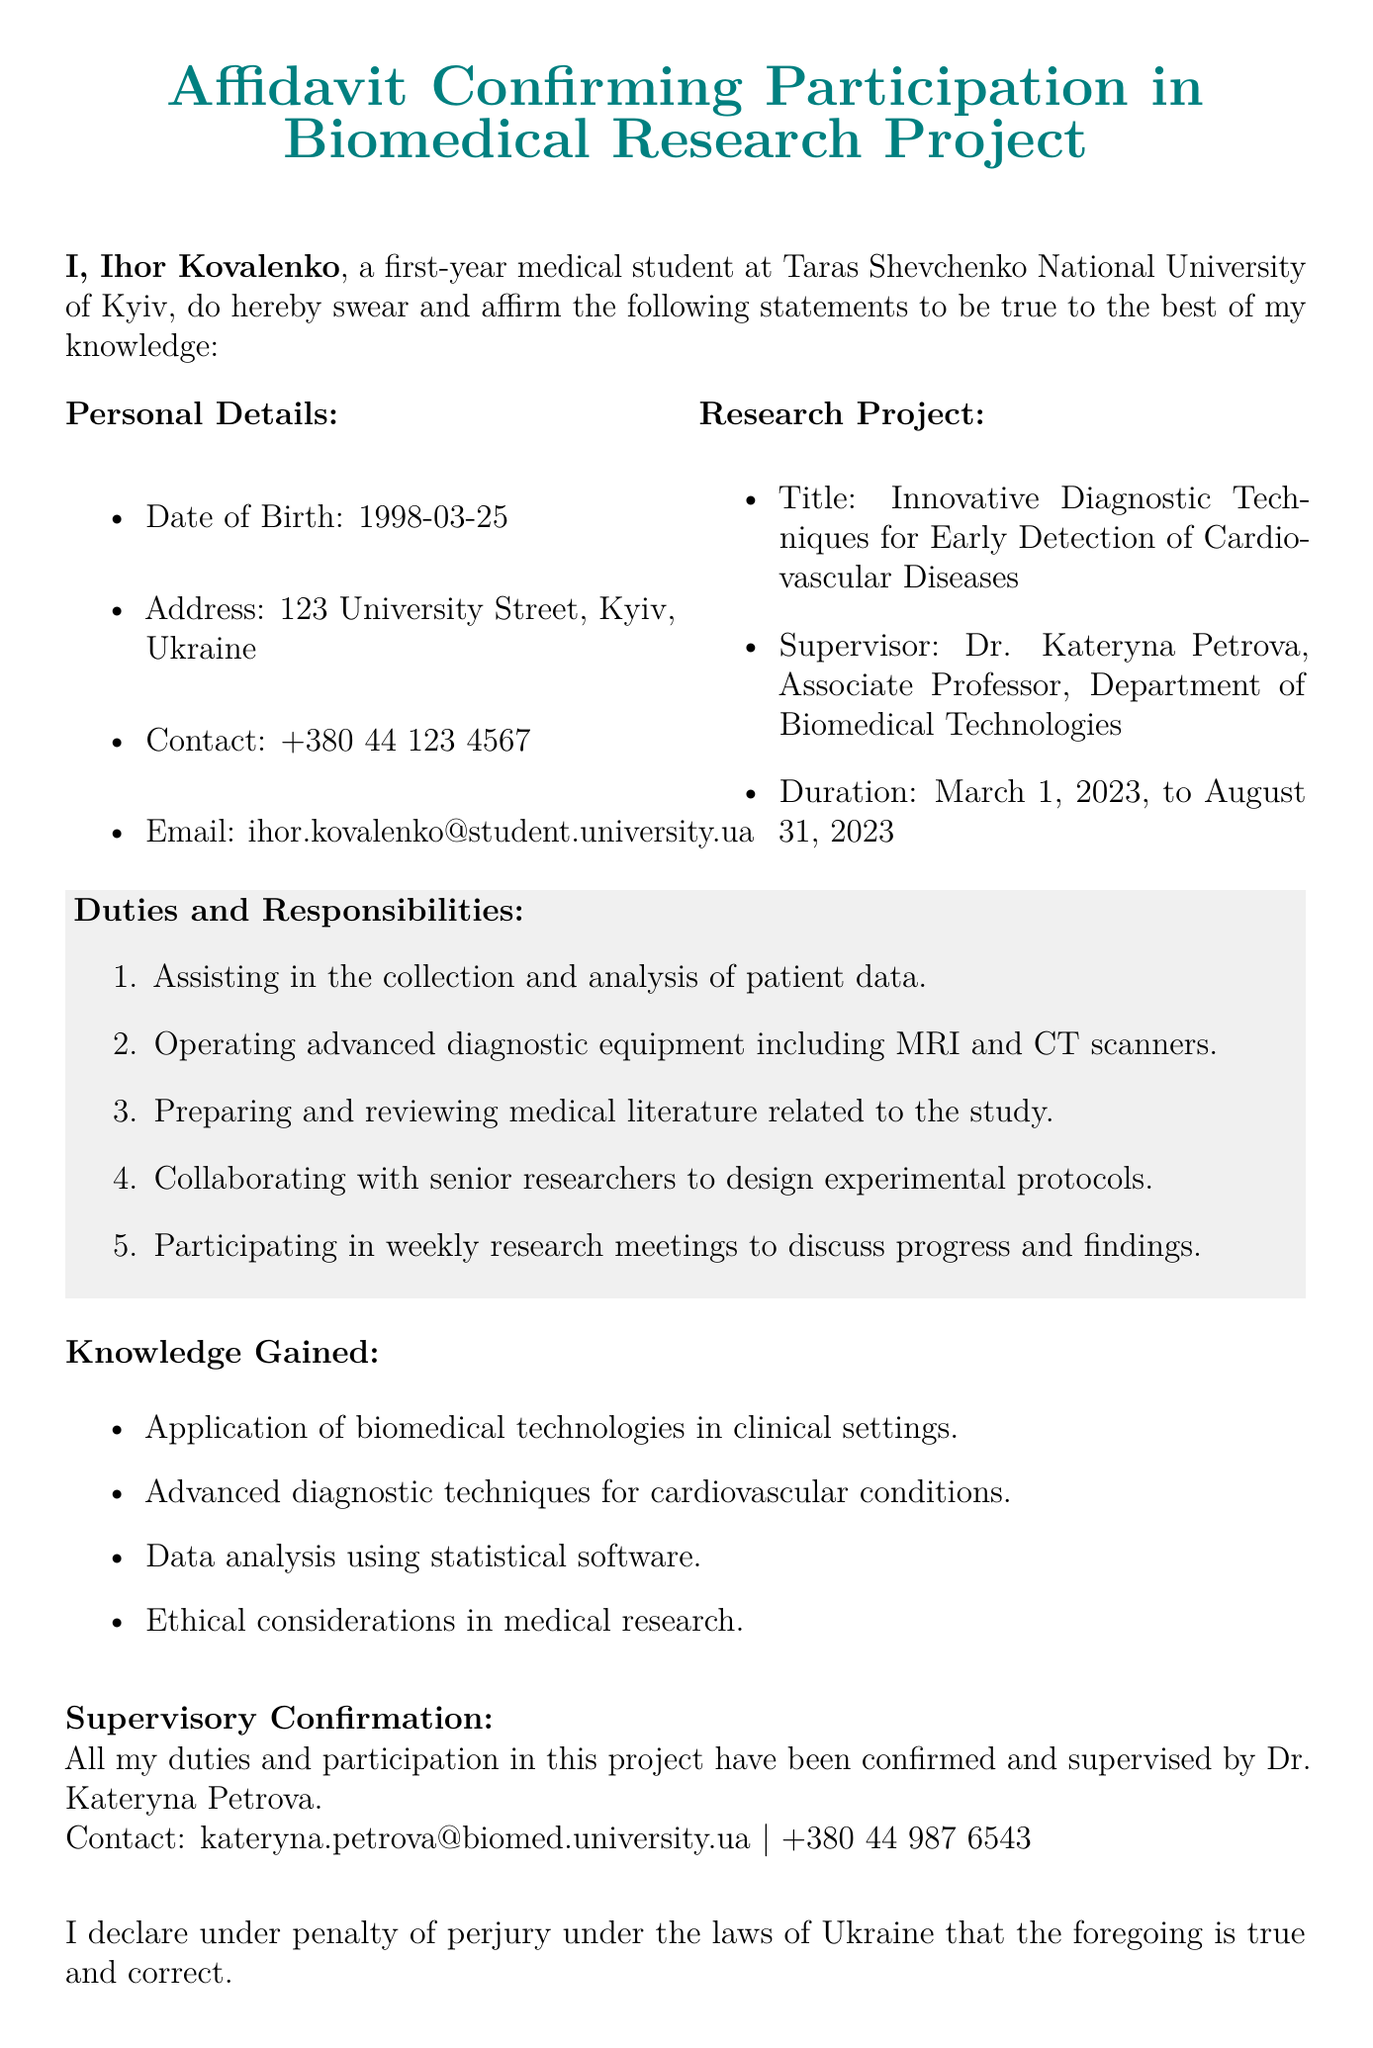What is the full name of the participant? The full name of the participant is provided at the beginning of the document.
Answer: Ihor Kovalenko What is the title of the research project? The title of the research project is explicitly mentioned in the document.
Answer: Innovative Diagnostic Techniques for Early Detection of Cardiovascular Diseases Who is the supervisor of the project? The supervisor's name is stated under the research project section.
Answer: Dr. Kateryna Petrova What is the duration of the research project? The duration is stated as a specific date range in the document.
Answer: March 1, 2023, to August 31, 2023 What responsibilities does the participant have? The document lists multiple duties of the participant.
Answer: Assisting in the collection and analysis of patient data, Operating advanced diagnostic equipment including MRI and CT scanners, Preparing and reviewing medical literature related to the study, Collaborating with senior researchers to design experimental protocols, Participating in weekly research meetings to discuss progress and findings What knowledge was gained through participation? The knowledge gained is outlined as a list in the document.
Answer: Application of biomedical technologies in clinical settings Who confirmed the participant's duties? The document specifies who verified the participant's involvement in the project.
Answer: Dr. Kateryna Petrova What is the contact email of the supervisor? The contact email of the supervisor is listed under the supervisory confirmation section.
Answer: kateryna.petrova@biomed.university.ua What is the name of the witness? The witness's name is mentioned at the end of the document.
Answer: Oleg Shevchenko 